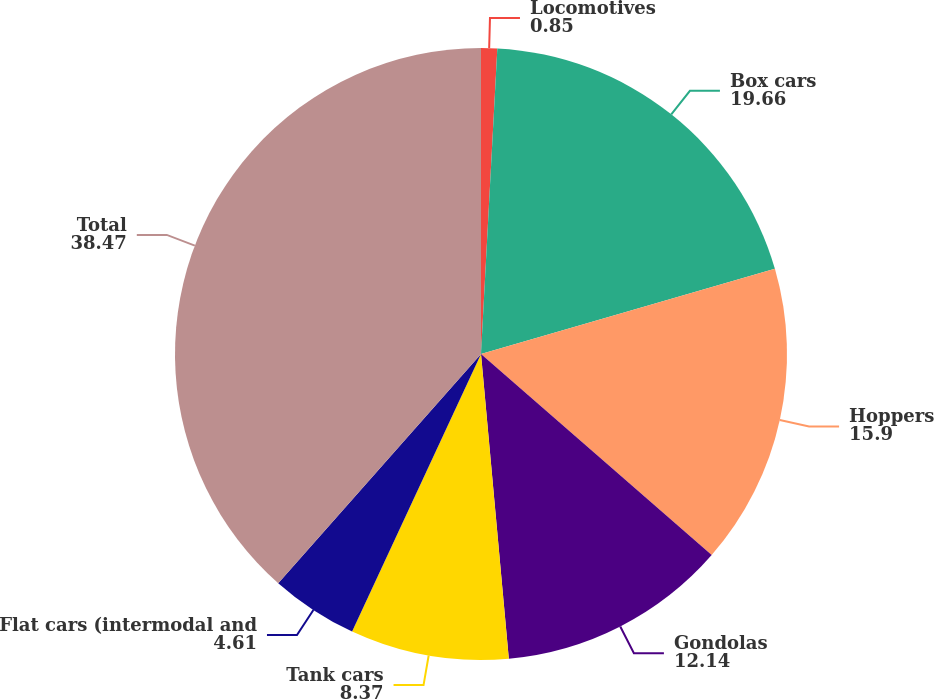Convert chart to OTSL. <chart><loc_0><loc_0><loc_500><loc_500><pie_chart><fcel>Locomotives<fcel>Box cars<fcel>Hoppers<fcel>Gondolas<fcel>Tank cars<fcel>Flat cars (intermodal and<fcel>Total<nl><fcel>0.85%<fcel>19.66%<fcel>15.9%<fcel>12.14%<fcel>8.37%<fcel>4.61%<fcel>38.47%<nl></chart> 